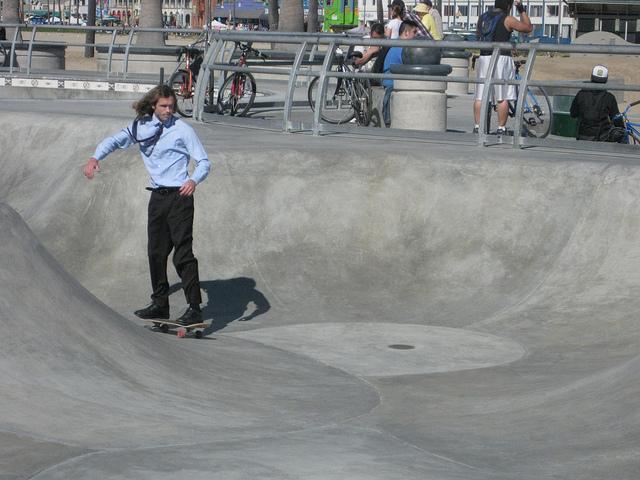How many people are in the picture?
Give a very brief answer. 3. How many bicycles are visible?
Give a very brief answer. 2. 